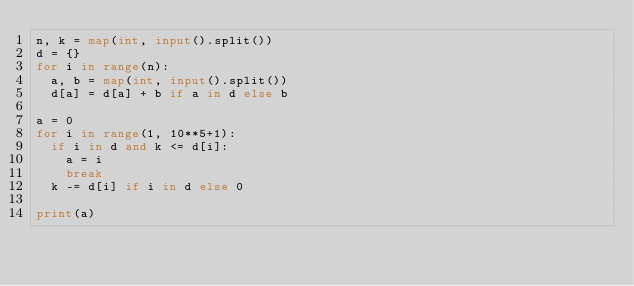<code> <loc_0><loc_0><loc_500><loc_500><_Python_>n, k = map(int, input().split())
d = {}
for i in range(n):
  a, b = map(int, input().split())
  d[a] = d[a] + b if a in d else b
 
a = 0
for i in range(1, 10**5+1):
  if i in d and k <= d[i]:
    a = i
    break
  k -= d[i] if i in d else 0
 
print(a)</code> 